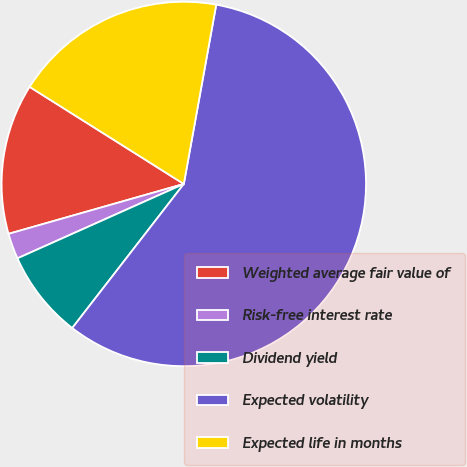Convert chart. <chart><loc_0><loc_0><loc_500><loc_500><pie_chart><fcel>Weighted average fair value of<fcel>Risk-free interest rate<fcel>Dividend yield<fcel>Expected volatility<fcel>Expected life in months<nl><fcel>13.36%<fcel>2.28%<fcel>7.82%<fcel>57.64%<fcel>18.9%<nl></chart> 